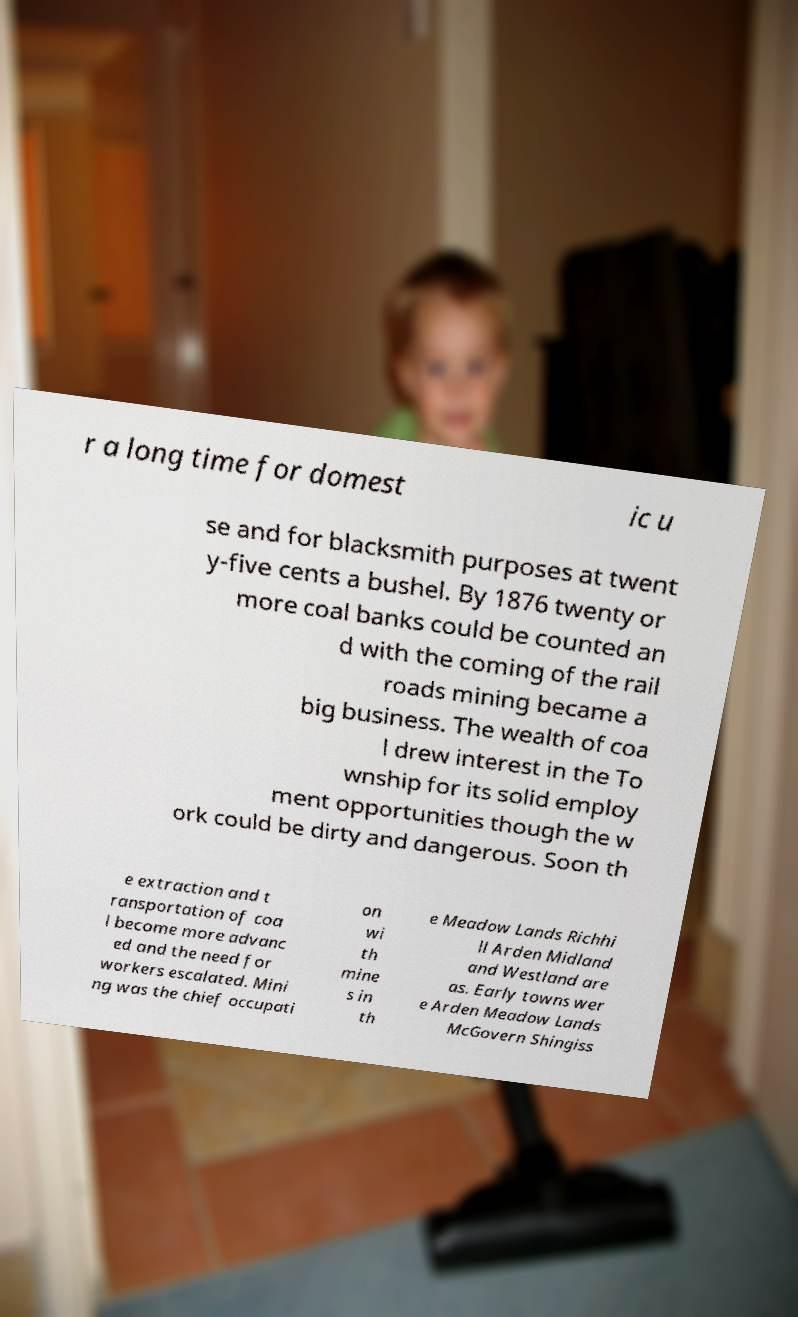Please identify and transcribe the text found in this image. r a long time for domest ic u se and for blacksmith purposes at twent y-five cents a bushel. By 1876 twenty or more coal banks could be counted an d with the coming of the rail roads mining became a big business. The wealth of coa l drew interest in the To wnship for its solid employ ment opportunities though the w ork could be dirty and dangerous. Soon th e extraction and t ransportation of coa l become more advanc ed and the need for workers escalated. Mini ng was the chief occupati on wi th mine s in th e Meadow Lands Richhi ll Arden Midland and Westland are as. Early towns wer e Arden Meadow Lands McGovern Shingiss 